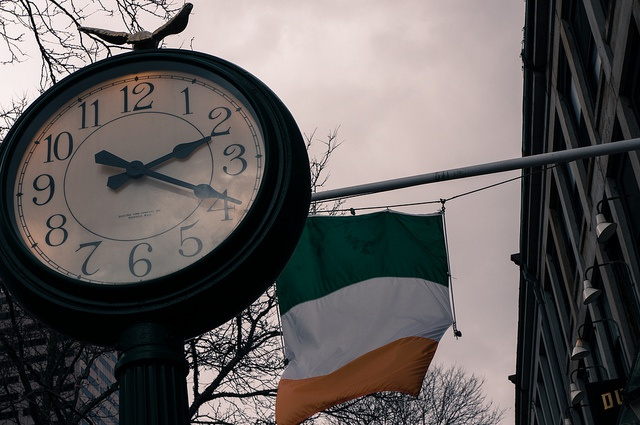Describe the objects in this image and their specific colors. I can see a clock in lavender, gray, and black tones in this image. 